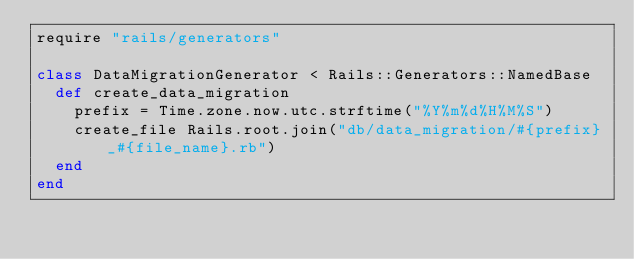Convert code to text. <code><loc_0><loc_0><loc_500><loc_500><_Ruby_>require "rails/generators"

class DataMigrationGenerator < Rails::Generators::NamedBase
  def create_data_migration
    prefix = Time.zone.now.utc.strftime("%Y%m%d%H%M%S")
    create_file Rails.root.join("db/data_migration/#{prefix}_#{file_name}.rb")
  end
end
</code> 